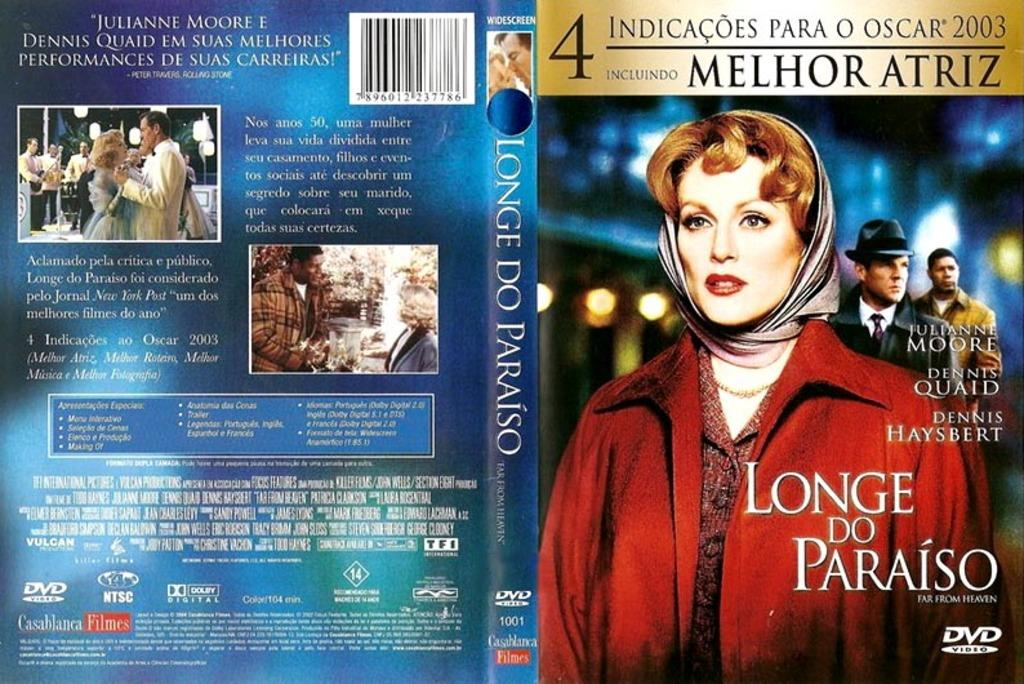<image>
Create a compact narrative representing the image presented. The display cover of a movie in spanish that has a lady in a red coat on the cover 